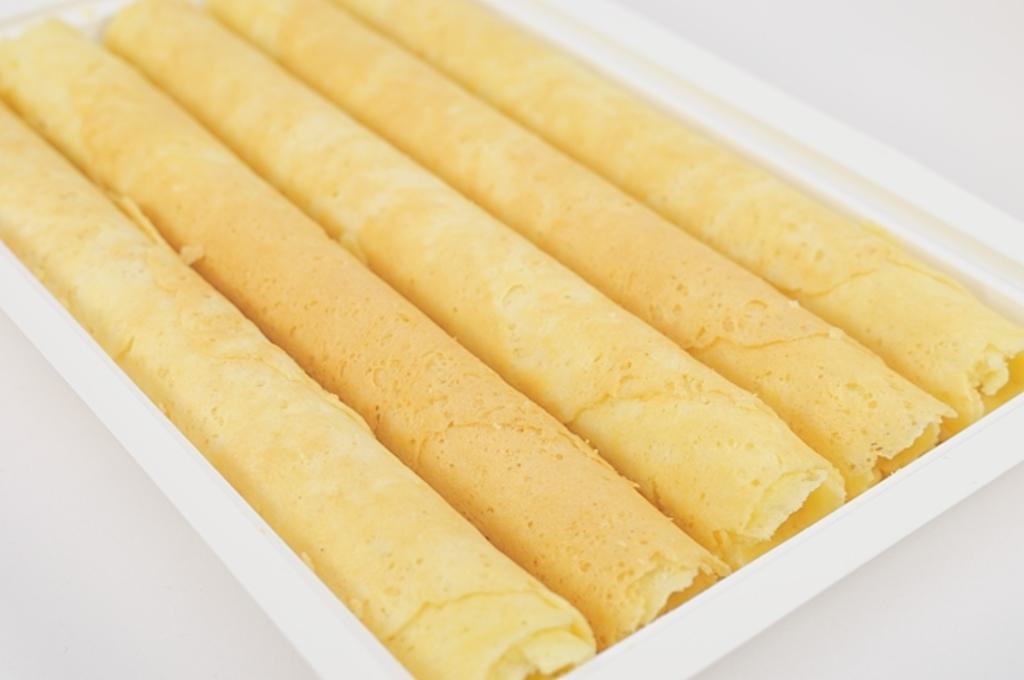Could you give a brief overview of what you see in this image? In this image I can see there are food items in a white color box. 